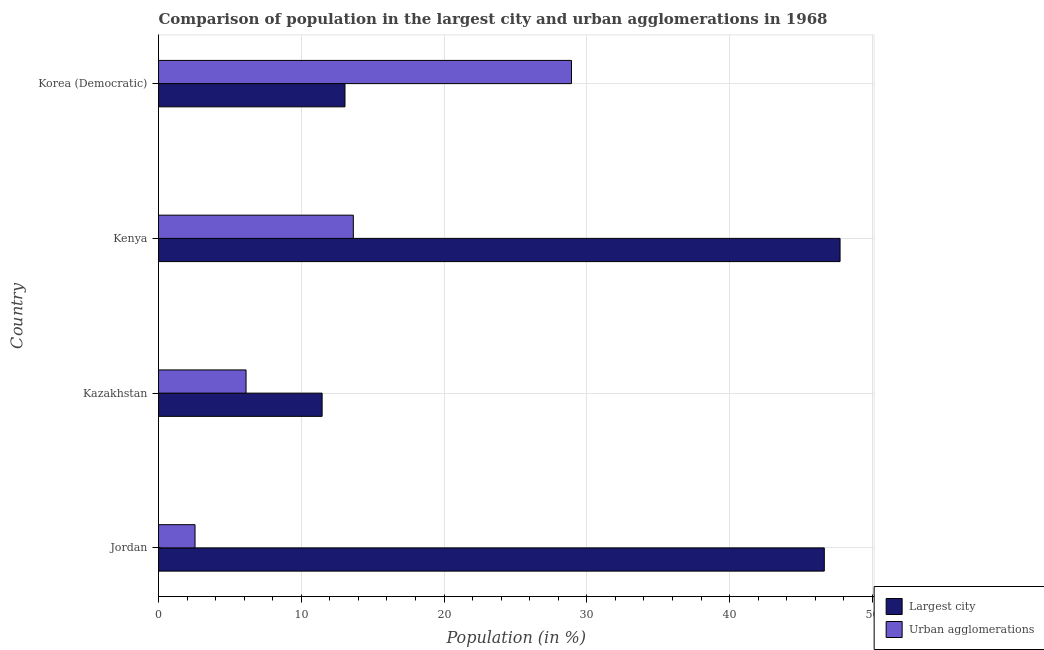How many groups of bars are there?
Keep it short and to the point. 4. How many bars are there on the 4th tick from the top?
Your response must be concise. 2. What is the label of the 1st group of bars from the top?
Give a very brief answer. Korea (Democratic). What is the population in the largest city in Korea (Democratic)?
Keep it short and to the point. 13.06. Across all countries, what is the maximum population in urban agglomerations?
Ensure brevity in your answer.  28.92. Across all countries, what is the minimum population in urban agglomerations?
Provide a succinct answer. 2.56. In which country was the population in urban agglomerations maximum?
Keep it short and to the point. Korea (Democratic). In which country was the population in the largest city minimum?
Make the answer very short. Kazakhstan. What is the total population in the largest city in the graph?
Offer a very short reply. 118.89. What is the difference between the population in urban agglomerations in Jordan and that in Korea (Democratic)?
Offer a terse response. -26.37. What is the difference between the population in the largest city in Kenya and the population in urban agglomerations in Kazakhstan?
Provide a short and direct response. 41.6. What is the average population in the largest city per country?
Your response must be concise. 29.72. What is the difference between the population in urban agglomerations and population in the largest city in Korea (Democratic)?
Provide a succinct answer. 15.87. In how many countries, is the population in urban agglomerations greater than 30 %?
Your answer should be very brief. 0. What is the ratio of the population in the largest city in Kazakhstan to that in Korea (Democratic)?
Ensure brevity in your answer.  0.88. Is the difference between the population in urban agglomerations in Jordan and Kazakhstan greater than the difference between the population in the largest city in Jordan and Kazakhstan?
Keep it short and to the point. No. What is the difference between the highest and the second highest population in the largest city?
Provide a short and direct response. 1.1. What is the difference between the highest and the lowest population in the largest city?
Give a very brief answer. 36.28. In how many countries, is the population in urban agglomerations greater than the average population in urban agglomerations taken over all countries?
Provide a short and direct response. 2. Is the sum of the population in the largest city in Kenya and Korea (Democratic) greater than the maximum population in urban agglomerations across all countries?
Keep it short and to the point. Yes. What does the 1st bar from the top in Kenya represents?
Make the answer very short. Urban agglomerations. What does the 2nd bar from the bottom in Kenya represents?
Your response must be concise. Urban agglomerations. How many bars are there?
Make the answer very short. 8. Are the values on the major ticks of X-axis written in scientific E-notation?
Your answer should be very brief. No. Does the graph contain grids?
Your response must be concise. Yes. Where does the legend appear in the graph?
Your answer should be very brief. Bottom right. How many legend labels are there?
Ensure brevity in your answer.  2. What is the title of the graph?
Make the answer very short. Comparison of population in the largest city and urban agglomerations in 1968. What is the Population (in %) of Largest city in Jordan?
Your answer should be compact. 46.63. What is the Population (in %) of Urban agglomerations in Jordan?
Your answer should be compact. 2.56. What is the Population (in %) of Largest city in Kazakhstan?
Make the answer very short. 11.46. What is the Population (in %) in Urban agglomerations in Kazakhstan?
Ensure brevity in your answer.  6.13. What is the Population (in %) of Largest city in Kenya?
Your response must be concise. 47.74. What is the Population (in %) in Urban agglomerations in Kenya?
Provide a succinct answer. 13.64. What is the Population (in %) in Largest city in Korea (Democratic)?
Your answer should be very brief. 13.06. What is the Population (in %) in Urban agglomerations in Korea (Democratic)?
Ensure brevity in your answer.  28.92. Across all countries, what is the maximum Population (in %) of Largest city?
Give a very brief answer. 47.74. Across all countries, what is the maximum Population (in %) in Urban agglomerations?
Keep it short and to the point. 28.92. Across all countries, what is the minimum Population (in %) of Largest city?
Your answer should be very brief. 11.46. Across all countries, what is the minimum Population (in %) of Urban agglomerations?
Offer a very short reply. 2.56. What is the total Population (in %) in Largest city in the graph?
Make the answer very short. 118.89. What is the total Population (in %) in Urban agglomerations in the graph?
Your answer should be very brief. 51.26. What is the difference between the Population (in %) in Largest city in Jordan and that in Kazakhstan?
Offer a very short reply. 35.17. What is the difference between the Population (in %) in Urban agglomerations in Jordan and that in Kazakhstan?
Ensure brevity in your answer.  -3.57. What is the difference between the Population (in %) of Largest city in Jordan and that in Kenya?
Your answer should be very brief. -1.1. What is the difference between the Population (in %) in Urban agglomerations in Jordan and that in Kenya?
Offer a very short reply. -11.09. What is the difference between the Population (in %) in Largest city in Jordan and that in Korea (Democratic)?
Your answer should be compact. 33.57. What is the difference between the Population (in %) of Urban agglomerations in Jordan and that in Korea (Democratic)?
Offer a terse response. -26.37. What is the difference between the Population (in %) in Largest city in Kazakhstan and that in Kenya?
Offer a very short reply. -36.28. What is the difference between the Population (in %) in Urban agglomerations in Kazakhstan and that in Kenya?
Offer a terse response. -7.51. What is the difference between the Population (in %) in Largest city in Kazakhstan and that in Korea (Democratic)?
Ensure brevity in your answer.  -1.6. What is the difference between the Population (in %) of Urban agglomerations in Kazakhstan and that in Korea (Democratic)?
Keep it short and to the point. -22.79. What is the difference between the Population (in %) in Largest city in Kenya and that in Korea (Democratic)?
Provide a short and direct response. 34.68. What is the difference between the Population (in %) of Urban agglomerations in Kenya and that in Korea (Democratic)?
Provide a succinct answer. -15.28. What is the difference between the Population (in %) of Largest city in Jordan and the Population (in %) of Urban agglomerations in Kazakhstan?
Offer a very short reply. 40.5. What is the difference between the Population (in %) in Largest city in Jordan and the Population (in %) in Urban agglomerations in Kenya?
Ensure brevity in your answer.  32.99. What is the difference between the Population (in %) in Largest city in Jordan and the Population (in %) in Urban agglomerations in Korea (Democratic)?
Give a very brief answer. 17.71. What is the difference between the Population (in %) in Largest city in Kazakhstan and the Population (in %) in Urban agglomerations in Kenya?
Your response must be concise. -2.19. What is the difference between the Population (in %) of Largest city in Kazakhstan and the Population (in %) of Urban agglomerations in Korea (Democratic)?
Provide a succinct answer. -17.47. What is the difference between the Population (in %) of Largest city in Kenya and the Population (in %) of Urban agglomerations in Korea (Democratic)?
Your answer should be very brief. 18.81. What is the average Population (in %) of Largest city per country?
Your response must be concise. 29.72. What is the average Population (in %) of Urban agglomerations per country?
Give a very brief answer. 12.81. What is the difference between the Population (in %) of Largest city and Population (in %) of Urban agglomerations in Jordan?
Keep it short and to the point. 44.07. What is the difference between the Population (in %) of Largest city and Population (in %) of Urban agglomerations in Kazakhstan?
Give a very brief answer. 5.33. What is the difference between the Population (in %) of Largest city and Population (in %) of Urban agglomerations in Kenya?
Your answer should be compact. 34.09. What is the difference between the Population (in %) in Largest city and Population (in %) in Urban agglomerations in Korea (Democratic)?
Keep it short and to the point. -15.86. What is the ratio of the Population (in %) in Largest city in Jordan to that in Kazakhstan?
Offer a very short reply. 4.07. What is the ratio of the Population (in %) of Urban agglomerations in Jordan to that in Kazakhstan?
Give a very brief answer. 0.42. What is the ratio of the Population (in %) in Largest city in Jordan to that in Kenya?
Make the answer very short. 0.98. What is the ratio of the Population (in %) of Urban agglomerations in Jordan to that in Kenya?
Offer a terse response. 0.19. What is the ratio of the Population (in %) of Largest city in Jordan to that in Korea (Democratic)?
Your answer should be very brief. 3.57. What is the ratio of the Population (in %) of Urban agglomerations in Jordan to that in Korea (Democratic)?
Give a very brief answer. 0.09. What is the ratio of the Population (in %) of Largest city in Kazakhstan to that in Kenya?
Provide a succinct answer. 0.24. What is the ratio of the Population (in %) of Urban agglomerations in Kazakhstan to that in Kenya?
Your answer should be very brief. 0.45. What is the ratio of the Population (in %) in Largest city in Kazakhstan to that in Korea (Democratic)?
Keep it short and to the point. 0.88. What is the ratio of the Population (in %) of Urban agglomerations in Kazakhstan to that in Korea (Democratic)?
Offer a terse response. 0.21. What is the ratio of the Population (in %) of Largest city in Kenya to that in Korea (Democratic)?
Give a very brief answer. 3.66. What is the ratio of the Population (in %) in Urban agglomerations in Kenya to that in Korea (Democratic)?
Give a very brief answer. 0.47. What is the difference between the highest and the second highest Population (in %) in Largest city?
Your answer should be very brief. 1.1. What is the difference between the highest and the second highest Population (in %) of Urban agglomerations?
Make the answer very short. 15.28. What is the difference between the highest and the lowest Population (in %) in Largest city?
Make the answer very short. 36.28. What is the difference between the highest and the lowest Population (in %) of Urban agglomerations?
Provide a succinct answer. 26.37. 